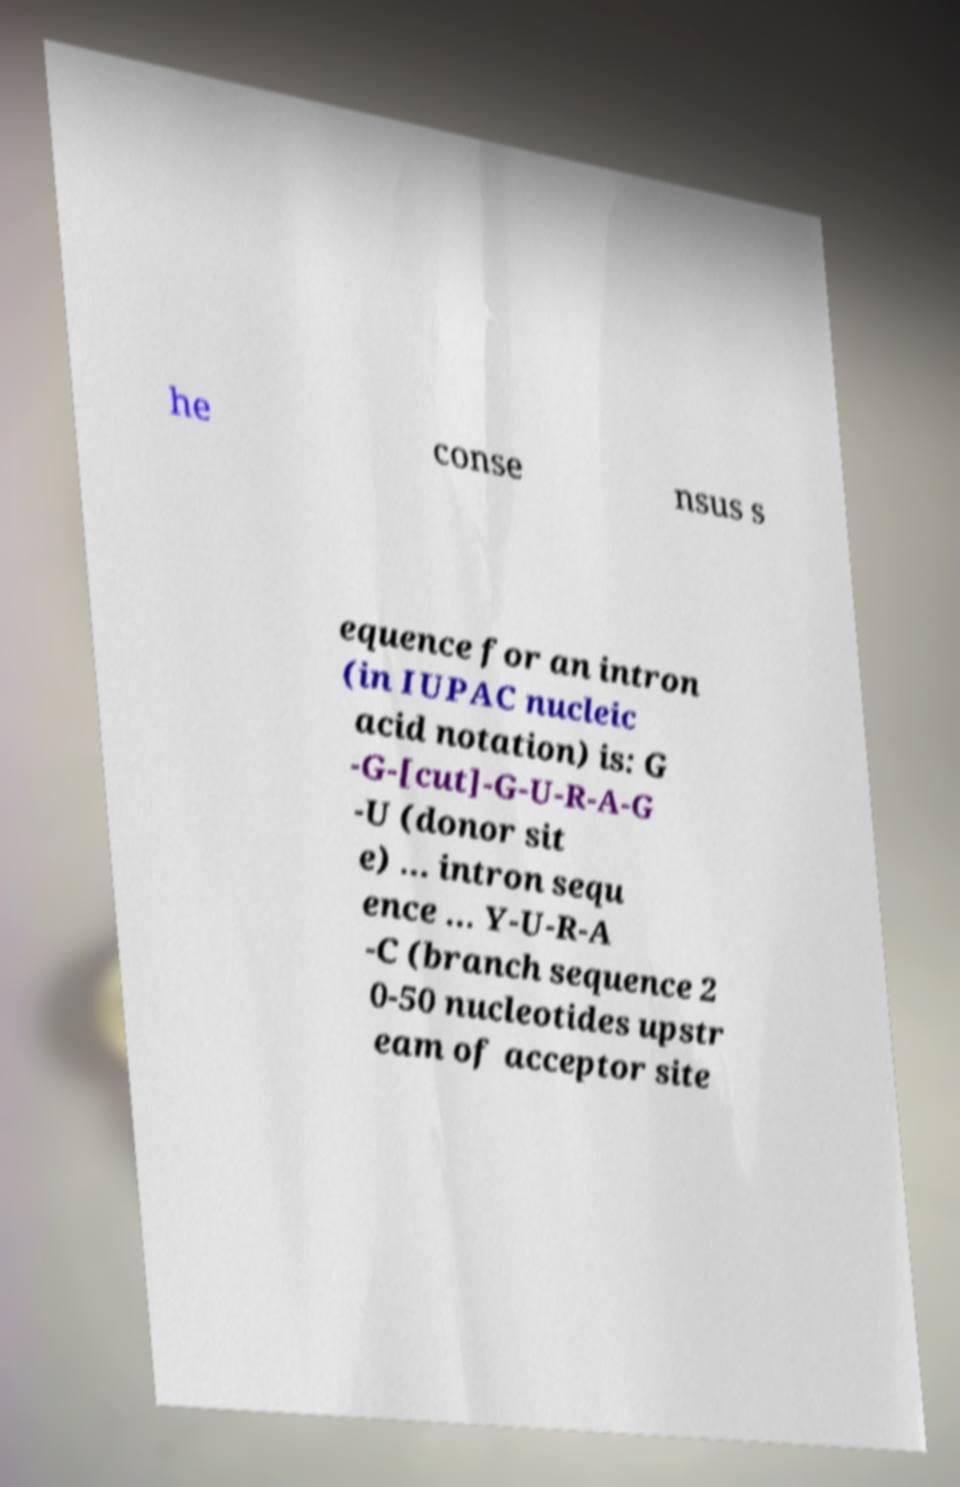Can you accurately transcribe the text from the provided image for me? he conse nsus s equence for an intron (in IUPAC nucleic acid notation) is: G -G-[cut]-G-U-R-A-G -U (donor sit e) ... intron sequ ence ... Y-U-R-A -C (branch sequence 2 0-50 nucleotides upstr eam of acceptor site 